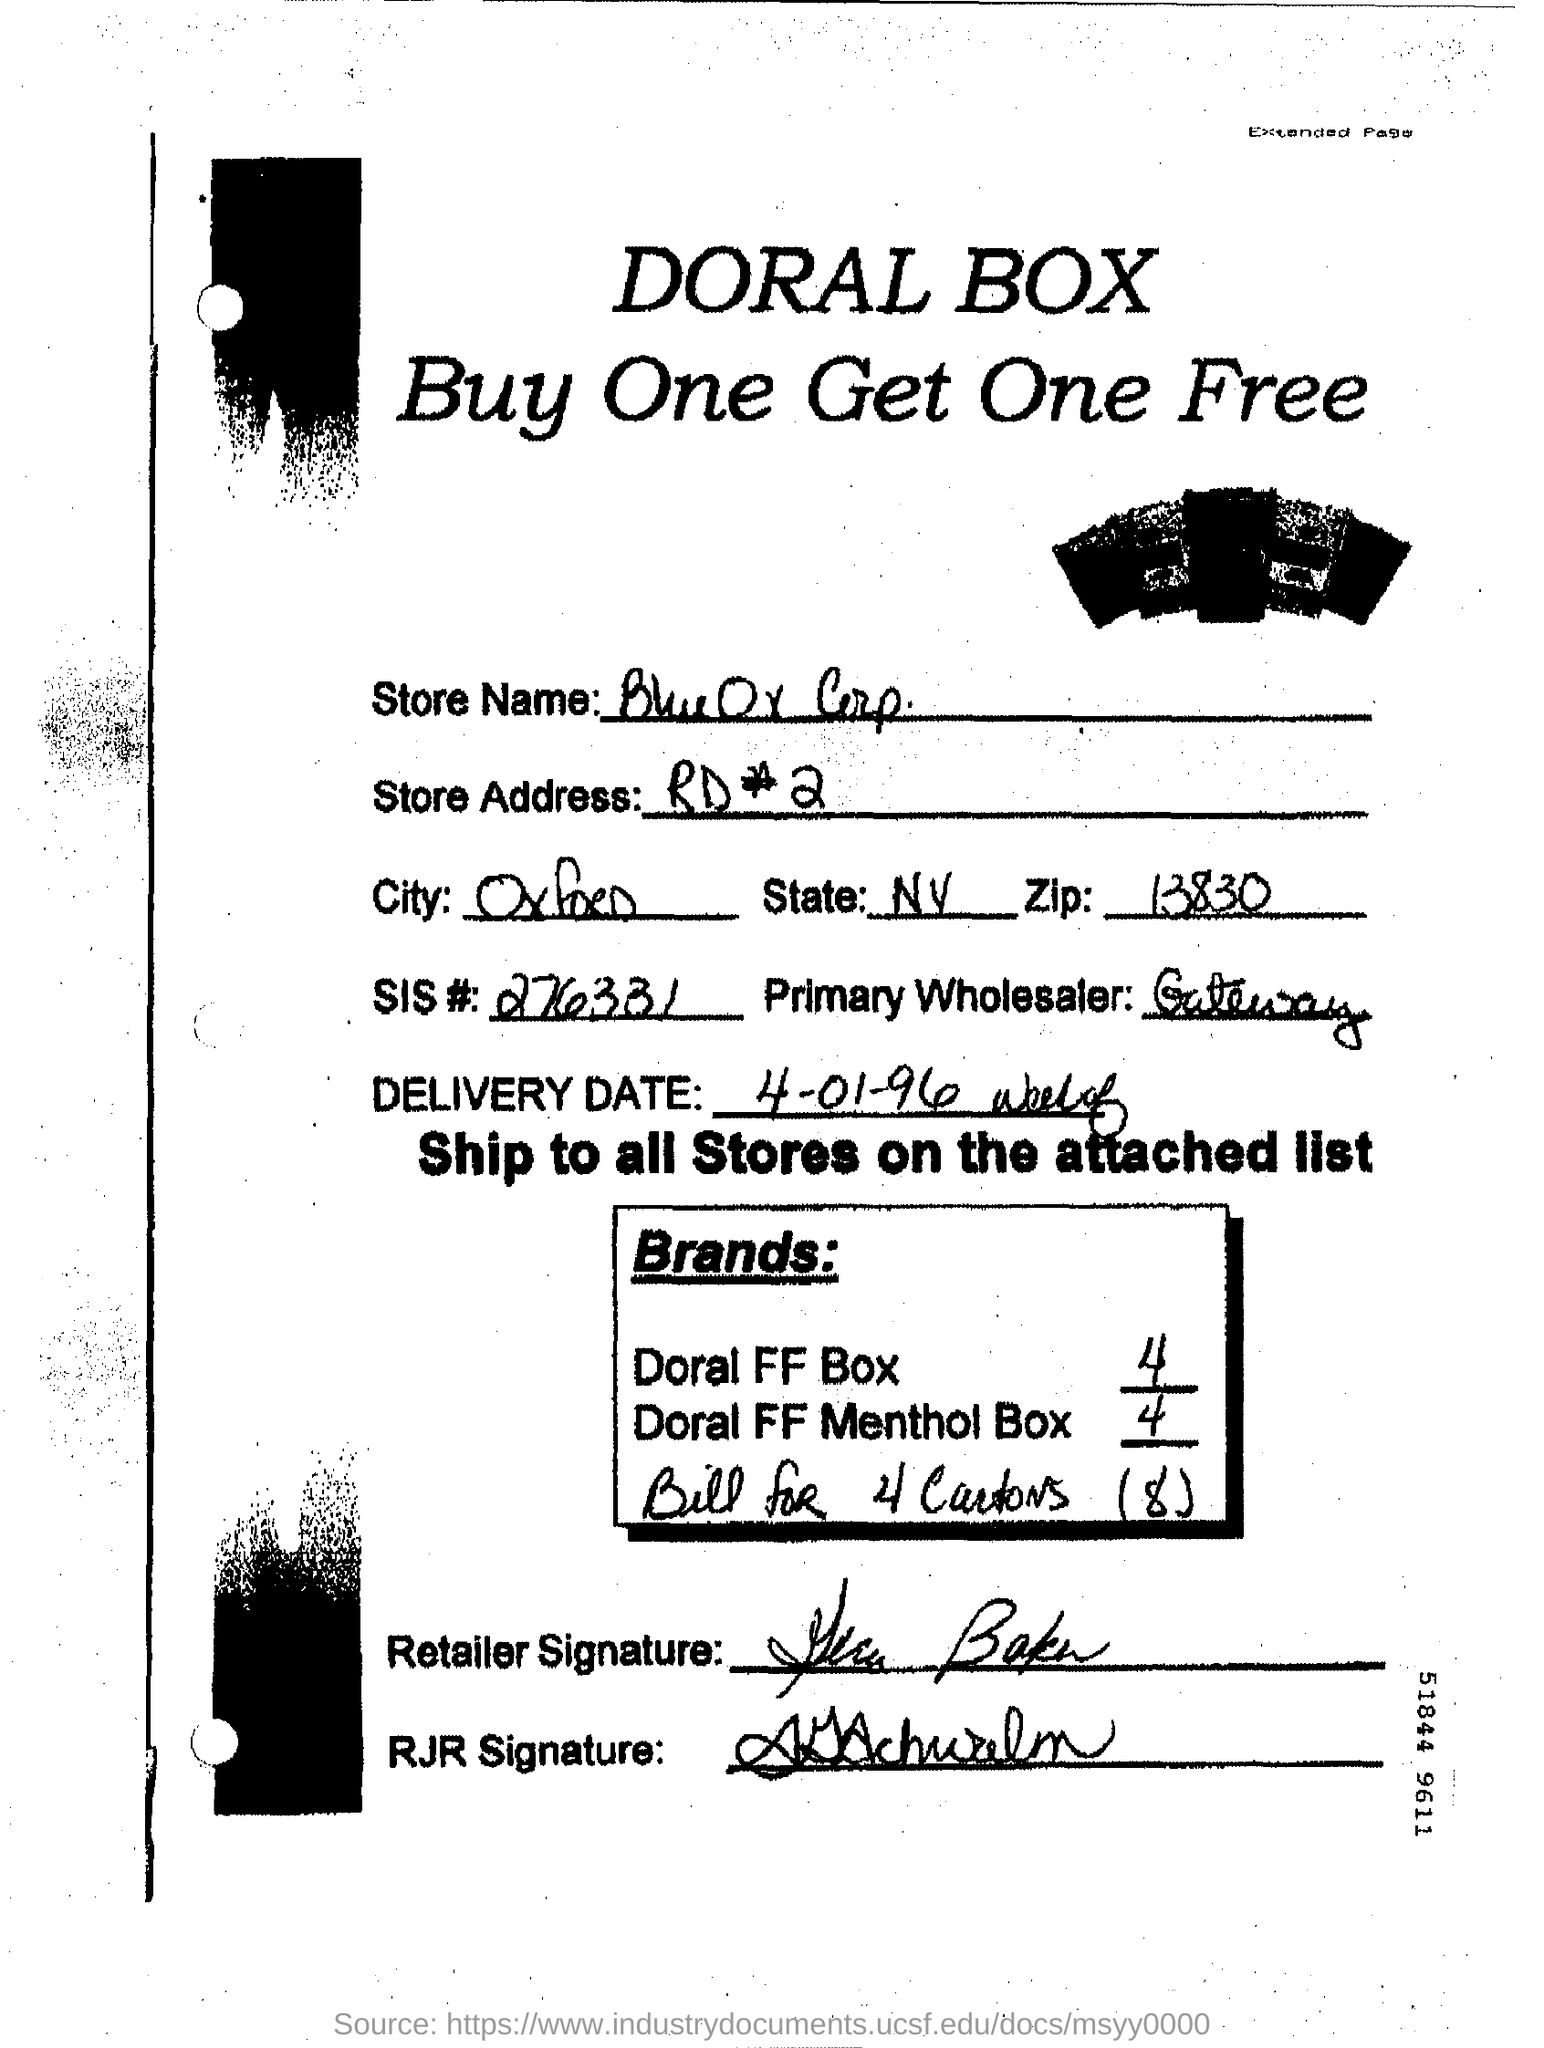Mention a couple of crucial points in this snapshot. The primary wholesaler is Gateway. 